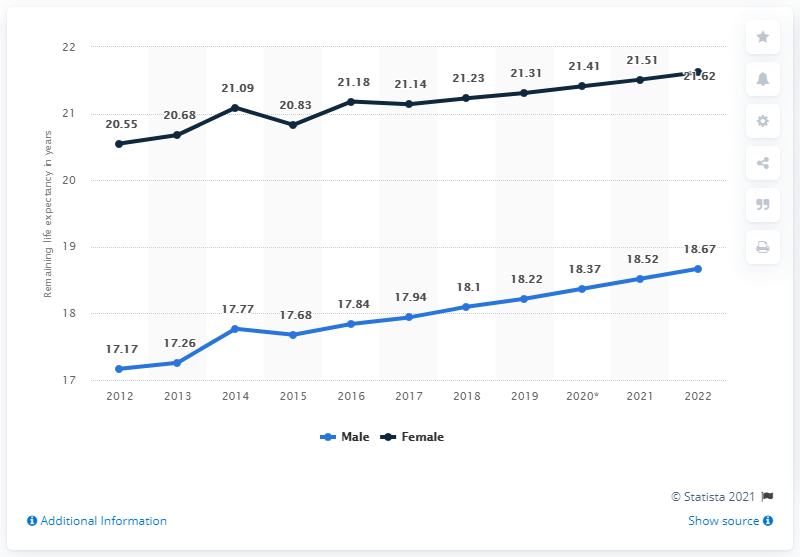Outline some significant characteristics in this image. The gray line represents females. For the first three years, the sum of the remaining life expectancy averages of both genders is 114.52. 